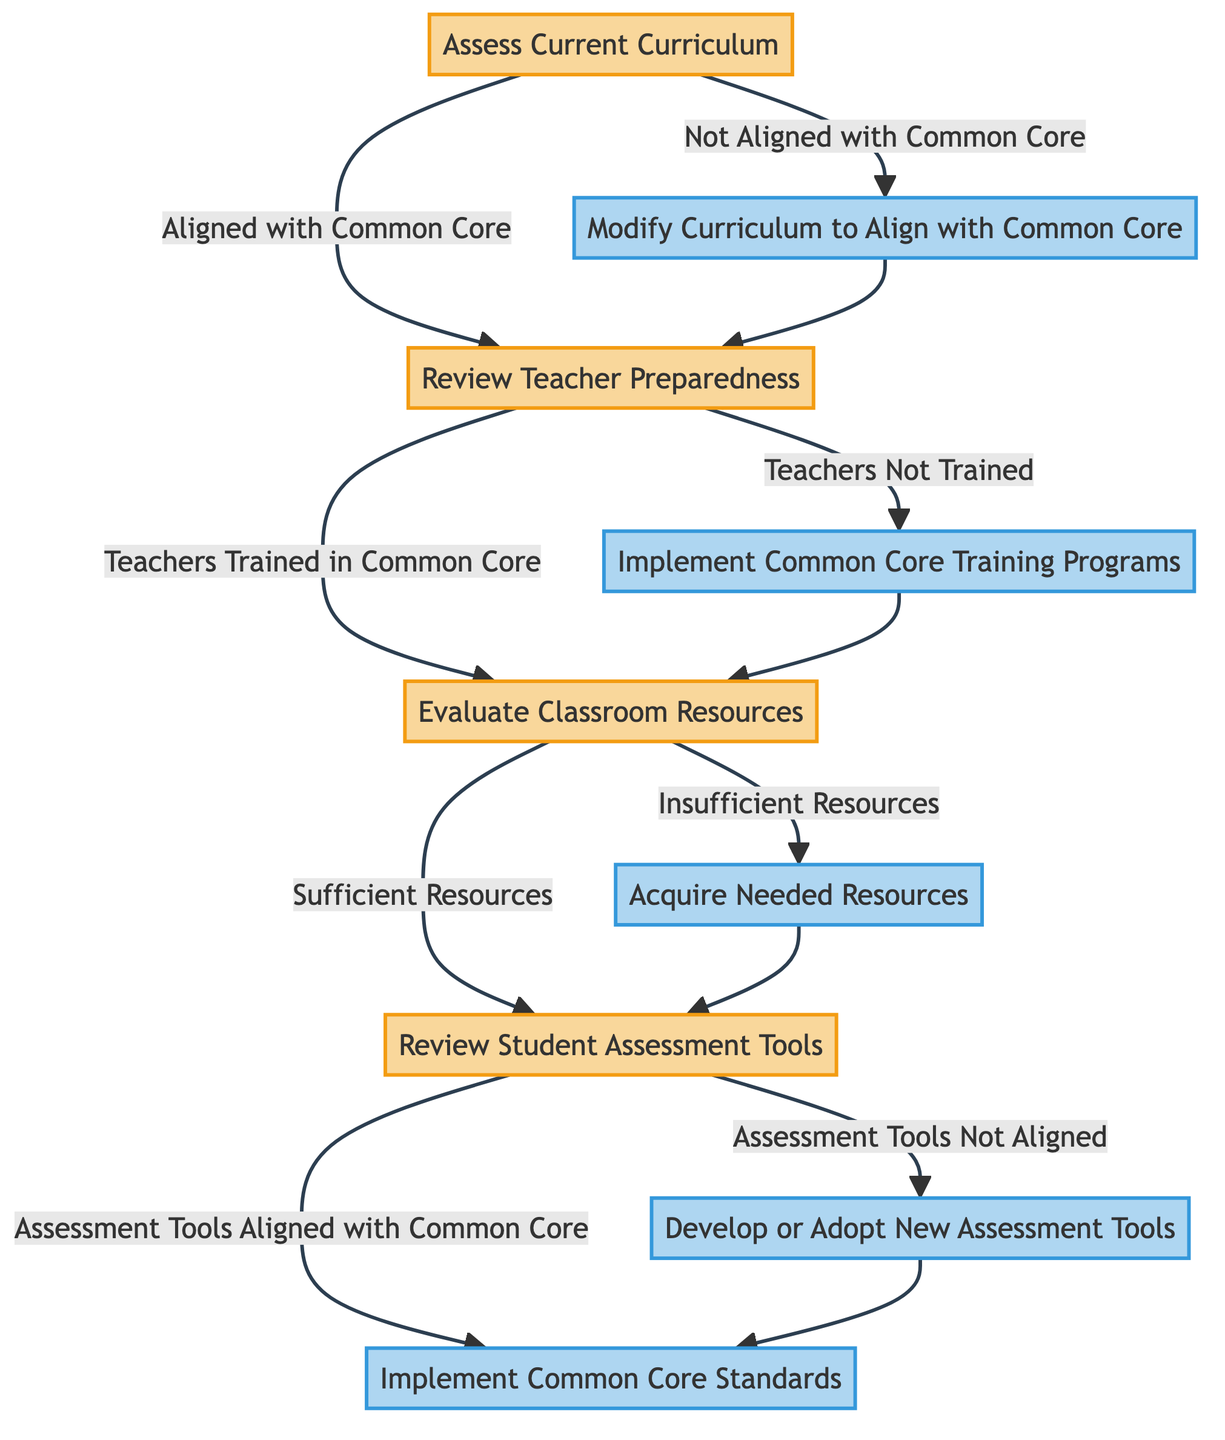What is the first step in the decision tree? The first step in the decision tree is "Assess Current Curriculum," which is where the process begins.
Answer: Assess Current Curriculum How many decision nodes are in the diagram? The diagram contains four decision nodes: "Assess Current Curriculum," "Review Teacher Preparedness," "Evaluate Classroom Resources," and "Review Student Assessment Tools."
Answer: Four What action is taken if the current curriculum is not aligned with Common Core? If the current curriculum is not aligned with Common Core, the action taken is "Modify Curriculum to Align with Common Core."
Answer: Modify Curriculum to Align with Common Core What follows after "Implement Common Core Training Programs"? After implementing Common Core training programs, the next step is to "Evaluate Classroom Resources."
Answer: Evaluate Classroom Resources What happens if sufficient resources are available during evaluation? If sufficient resources are available, the next step is to "Review Student Assessment Tools."
Answer: Review Student Assessment Tools What is the final action in the decision tree? The final action in the decision tree is "Implement Common Core Standards."
Answer: Implement Common Core Standards What leads to "Develop or Adopt New Assessment Tools"? If the assessment tools are not aligned with Common Core, this leads to "Develop or Adopt New Assessment Tools."
Answer: Develop or Adopt New Assessment Tools What can happen before implementing Common Core Standards? Before implementing Common Core Standards, it is necessary to ensure that the assessment tools are aligned with Common Core, or develop/adopt new ones if they are not.
Answer: Evaluate Classroom Resources How does the decision tree handle teacher preparedness? The decision tree addresses teacher preparedness by reviewing if teachers are trained in Common Core, directing to training programs if they are not.
Answer: Implement Common Core Training Programs 